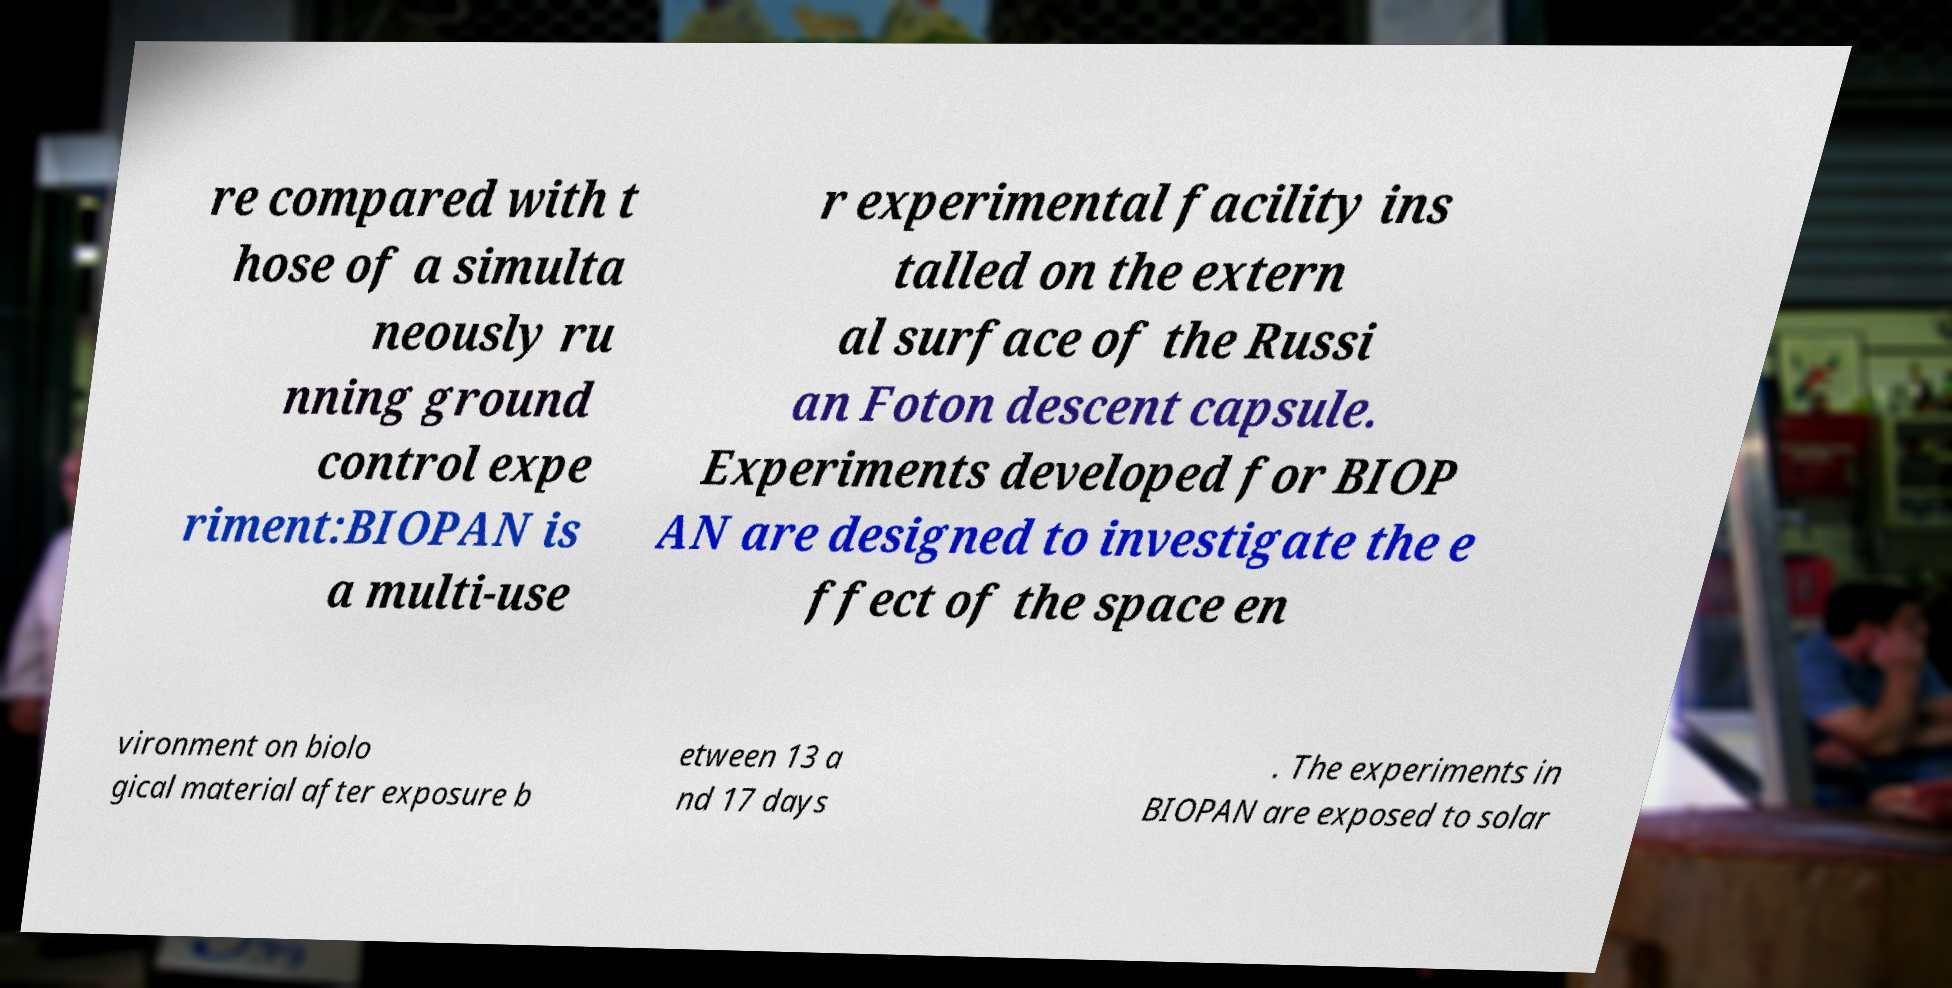Please read and relay the text visible in this image. What does it say? re compared with t hose of a simulta neously ru nning ground control expe riment:BIOPAN is a multi-use r experimental facility ins talled on the extern al surface of the Russi an Foton descent capsule. Experiments developed for BIOP AN are designed to investigate the e ffect of the space en vironment on biolo gical material after exposure b etween 13 a nd 17 days . The experiments in BIOPAN are exposed to solar 